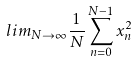Convert formula to latex. <formula><loc_0><loc_0><loc_500><loc_500>l i m _ { N \rightarrow \infty } \frac { 1 } { N } \sum _ { n = 0 } ^ { N - 1 } x _ { n } ^ { 2 }</formula> 